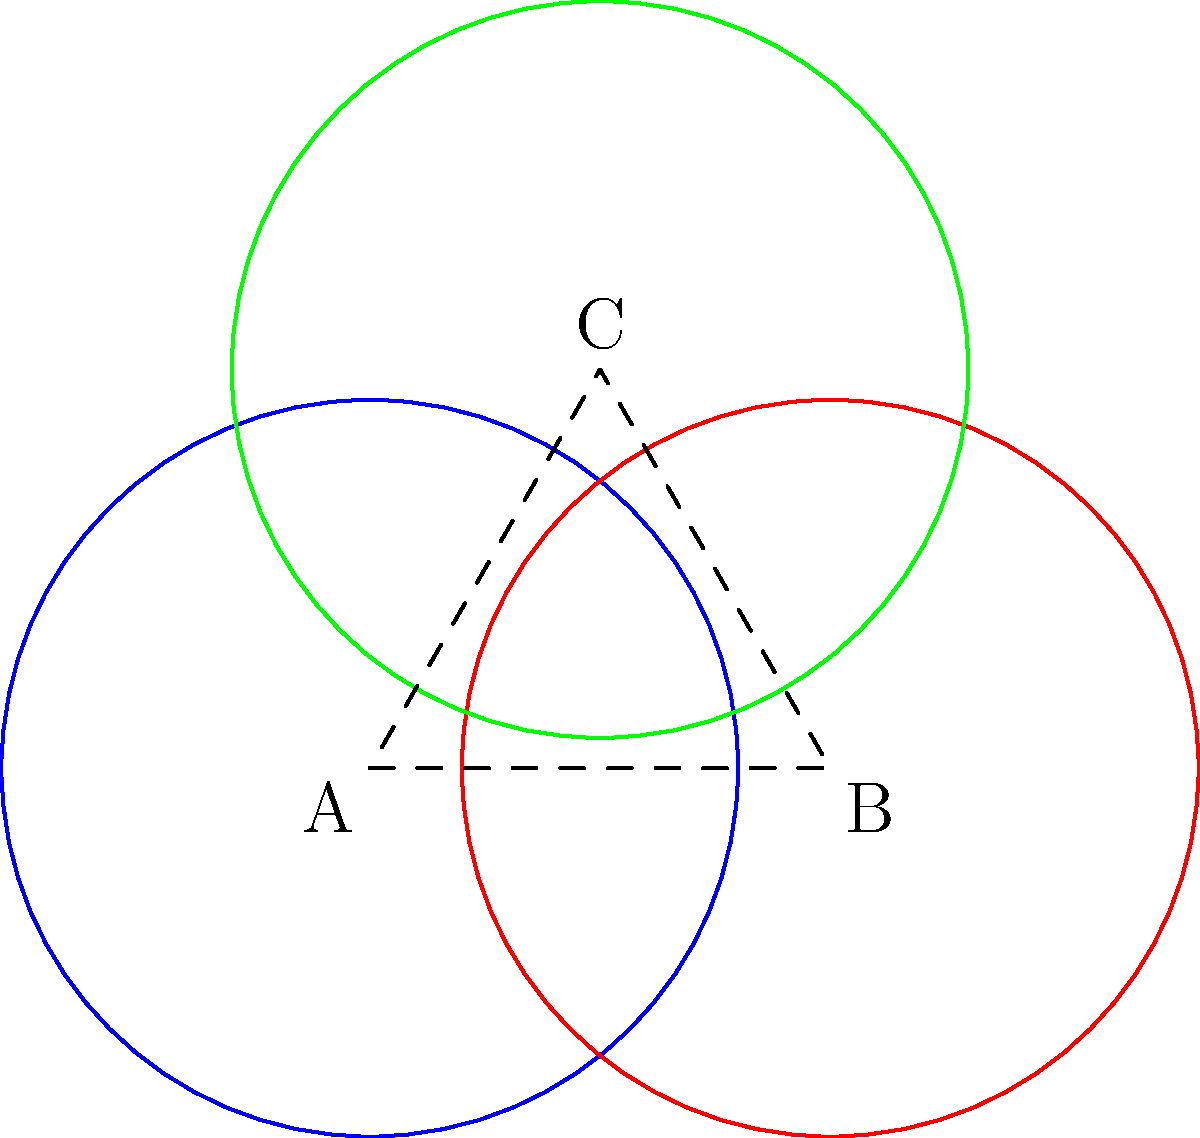As an outfielder, you're analyzing the defensive coverage of three players positioned at points A, B, and C. Each player can effectively cover a circular area with a radius of 40 yards. Calculate the total area covered by all three players, given that the distance between A and B is 50 yards, and C forms an equilateral triangle with A and B. Round your answer to the nearest square yard. Let's approach this step-by-step:

1) First, we need to calculate the area of a single circle:
   $A_{circle} = \pi r^2 = \pi (40)^2 = 1600\pi$ sq yards

2) The total area of three non-overlapping circles would be:
   $3 \times 1600\pi = 4800\pi$ sq yards

3) However, these circles overlap. We need to subtract the overlapping areas.

4) To find the overlapping areas, we need to calculate the distance between the centers:
   AB = 50 yards (given)
   AC = BC = 50 yards (equilateral triangle)

5) Now we can calculate the area of overlap between two circles using the formula:
   $A_{overlap} = 2r^2 \arccos(\frac{d}{2r}) - d\sqrt{r^2 - (\frac{d}{2})^2}$
   Where $r = 40$ and $d = 50$

6) Plugging in the values:
   $A_{overlap} = 2(40)^2 \arccos(\frac{50}{2(40)}) - 50\sqrt{40^2 - (\frac{50}{2})^2}$
   $= 3200 \arccos(0.625) - 50\sqrt{1600 - 625}$
   $\approx 1388.79$ sq yards

7) There are three such overlaps (AB, BC, and AC)

8) Finally, the area of the central region where all three circles overlap can be calculated, but it's a complex shape. For simplicity, we'll approximate it as a small equilateral triangle with side length about 10 yards:
   $A_{center} \approx \frac{\sqrt{3}}{4}(10)^2 \approx 43.3$ sq yards

9) Therefore, the total area covered is:
   $A_{total} = 3A_{circle} - 3A_{overlap} + A_{center}$
   $= 4800\pi - 3(1388.79) + 43.3$
   $\approx 10,748$ sq yards (rounded to nearest square yard)
Answer: 10,748 square yards 